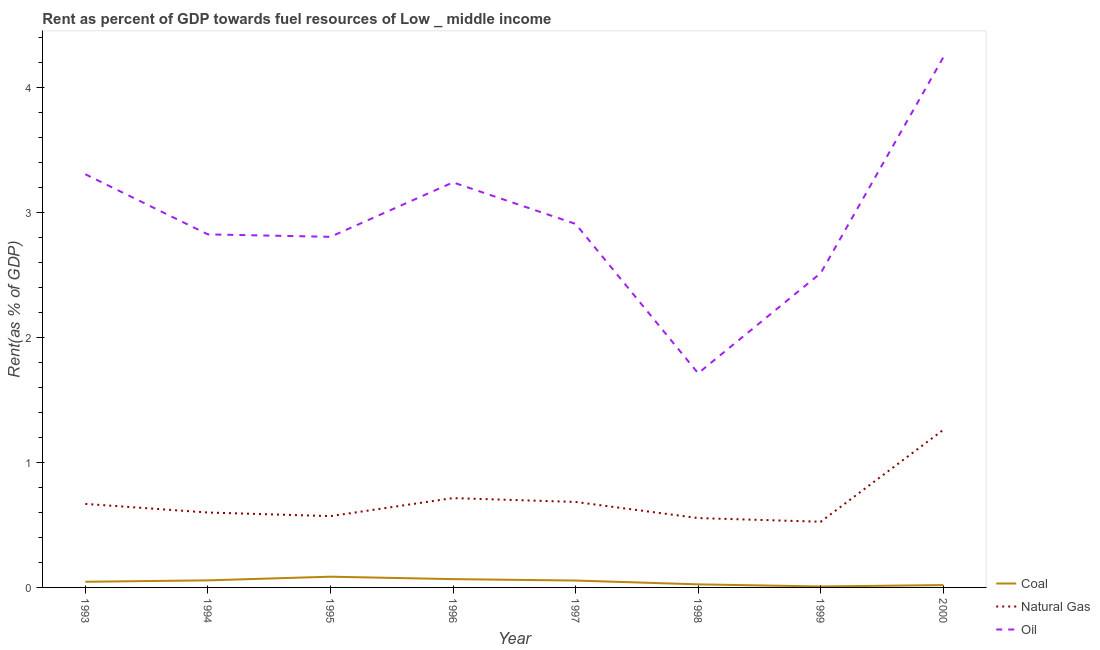Does the line corresponding to rent towards oil intersect with the line corresponding to rent towards natural gas?
Make the answer very short. No. Is the number of lines equal to the number of legend labels?
Your answer should be very brief. Yes. What is the rent towards coal in 1996?
Your answer should be very brief. 0.07. Across all years, what is the maximum rent towards natural gas?
Offer a very short reply. 1.26. Across all years, what is the minimum rent towards natural gas?
Keep it short and to the point. 0.53. In which year was the rent towards coal minimum?
Your response must be concise. 1999. What is the total rent towards coal in the graph?
Make the answer very short. 0.36. What is the difference between the rent towards coal in 1994 and that in 1996?
Your answer should be very brief. -0.01. What is the difference between the rent towards natural gas in 1997 and the rent towards coal in 1996?
Provide a short and direct response. 0.62. What is the average rent towards natural gas per year?
Make the answer very short. 0.7. In the year 1995, what is the difference between the rent towards coal and rent towards oil?
Ensure brevity in your answer.  -2.72. In how many years, is the rent towards coal greater than 3.2 %?
Keep it short and to the point. 0. What is the ratio of the rent towards coal in 1995 to that in 1996?
Your response must be concise. 1.29. Is the rent towards coal in 1994 less than that in 1998?
Provide a succinct answer. No. Is the difference between the rent towards natural gas in 1993 and 1998 greater than the difference between the rent towards coal in 1993 and 1998?
Keep it short and to the point. Yes. What is the difference between the highest and the second highest rent towards coal?
Make the answer very short. 0.02. What is the difference between the highest and the lowest rent towards oil?
Give a very brief answer. 2.53. In how many years, is the rent towards coal greater than the average rent towards coal taken over all years?
Your response must be concise. 5. Is the sum of the rent towards oil in 1994 and 1996 greater than the maximum rent towards natural gas across all years?
Offer a very short reply. Yes. Is it the case that in every year, the sum of the rent towards coal and rent towards natural gas is greater than the rent towards oil?
Ensure brevity in your answer.  No. Does the rent towards natural gas monotonically increase over the years?
Ensure brevity in your answer.  No. Is the rent towards oil strictly less than the rent towards coal over the years?
Give a very brief answer. No. How many years are there in the graph?
Provide a short and direct response. 8. Are the values on the major ticks of Y-axis written in scientific E-notation?
Your response must be concise. No. Where does the legend appear in the graph?
Offer a terse response. Bottom right. How many legend labels are there?
Ensure brevity in your answer.  3. What is the title of the graph?
Give a very brief answer. Rent as percent of GDP towards fuel resources of Low _ middle income. What is the label or title of the Y-axis?
Provide a succinct answer. Rent(as % of GDP). What is the Rent(as % of GDP) of Coal in 1993?
Provide a succinct answer. 0.05. What is the Rent(as % of GDP) in Natural Gas in 1993?
Make the answer very short. 0.67. What is the Rent(as % of GDP) in Oil in 1993?
Your answer should be compact. 3.3. What is the Rent(as % of GDP) of Coal in 1994?
Offer a very short reply. 0.06. What is the Rent(as % of GDP) of Natural Gas in 1994?
Your response must be concise. 0.6. What is the Rent(as % of GDP) in Oil in 1994?
Give a very brief answer. 2.82. What is the Rent(as % of GDP) of Coal in 1995?
Keep it short and to the point. 0.09. What is the Rent(as % of GDP) in Natural Gas in 1995?
Provide a succinct answer. 0.57. What is the Rent(as % of GDP) of Oil in 1995?
Provide a succinct answer. 2.8. What is the Rent(as % of GDP) in Coal in 1996?
Offer a terse response. 0.07. What is the Rent(as % of GDP) in Natural Gas in 1996?
Make the answer very short. 0.71. What is the Rent(as % of GDP) of Oil in 1996?
Make the answer very short. 3.24. What is the Rent(as % of GDP) of Coal in 1997?
Give a very brief answer. 0.06. What is the Rent(as % of GDP) of Natural Gas in 1997?
Your response must be concise. 0.68. What is the Rent(as % of GDP) in Oil in 1997?
Your response must be concise. 2.91. What is the Rent(as % of GDP) of Coal in 1998?
Keep it short and to the point. 0.02. What is the Rent(as % of GDP) of Natural Gas in 1998?
Provide a short and direct response. 0.55. What is the Rent(as % of GDP) of Oil in 1998?
Offer a very short reply. 1.71. What is the Rent(as % of GDP) of Coal in 1999?
Ensure brevity in your answer.  0.01. What is the Rent(as % of GDP) of Natural Gas in 1999?
Keep it short and to the point. 0.53. What is the Rent(as % of GDP) in Oil in 1999?
Keep it short and to the point. 2.51. What is the Rent(as % of GDP) of Coal in 2000?
Make the answer very short. 0.02. What is the Rent(as % of GDP) of Natural Gas in 2000?
Your answer should be compact. 1.26. What is the Rent(as % of GDP) in Oil in 2000?
Your response must be concise. 4.24. Across all years, what is the maximum Rent(as % of GDP) in Coal?
Your answer should be very brief. 0.09. Across all years, what is the maximum Rent(as % of GDP) of Natural Gas?
Give a very brief answer. 1.26. Across all years, what is the maximum Rent(as % of GDP) in Oil?
Offer a very short reply. 4.24. Across all years, what is the minimum Rent(as % of GDP) in Coal?
Provide a succinct answer. 0.01. Across all years, what is the minimum Rent(as % of GDP) in Natural Gas?
Give a very brief answer. 0.53. Across all years, what is the minimum Rent(as % of GDP) of Oil?
Keep it short and to the point. 1.71. What is the total Rent(as % of GDP) of Coal in the graph?
Your answer should be compact. 0.36. What is the total Rent(as % of GDP) in Natural Gas in the graph?
Keep it short and to the point. 5.57. What is the total Rent(as % of GDP) in Oil in the graph?
Ensure brevity in your answer.  23.54. What is the difference between the Rent(as % of GDP) in Coal in 1993 and that in 1994?
Offer a terse response. -0.01. What is the difference between the Rent(as % of GDP) of Natural Gas in 1993 and that in 1994?
Your response must be concise. 0.07. What is the difference between the Rent(as % of GDP) of Oil in 1993 and that in 1994?
Offer a very short reply. 0.48. What is the difference between the Rent(as % of GDP) in Coal in 1993 and that in 1995?
Your answer should be very brief. -0.04. What is the difference between the Rent(as % of GDP) in Natural Gas in 1993 and that in 1995?
Offer a terse response. 0.1. What is the difference between the Rent(as % of GDP) of Oil in 1993 and that in 1995?
Your answer should be compact. 0.5. What is the difference between the Rent(as % of GDP) of Coal in 1993 and that in 1996?
Your response must be concise. -0.02. What is the difference between the Rent(as % of GDP) of Natural Gas in 1993 and that in 1996?
Keep it short and to the point. -0.05. What is the difference between the Rent(as % of GDP) of Oil in 1993 and that in 1996?
Your response must be concise. 0.07. What is the difference between the Rent(as % of GDP) in Coal in 1993 and that in 1997?
Make the answer very short. -0.01. What is the difference between the Rent(as % of GDP) of Natural Gas in 1993 and that in 1997?
Give a very brief answer. -0.02. What is the difference between the Rent(as % of GDP) of Oil in 1993 and that in 1997?
Provide a short and direct response. 0.4. What is the difference between the Rent(as % of GDP) in Coal in 1993 and that in 1998?
Offer a very short reply. 0.02. What is the difference between the Rent(as % of GDP) of Natural Gas in 1993 and that in 1998?
Provide a short and direct response. 0.11. What is the difference between the Rent(as % of GDP) in Oil in 1993 and that in 1998?
Your answer should be very brief. 1.59. What is the difference between the Rent(as % of GDP) in Coal in 1993 and that in 1999?
Your response must be concise. 0.04. What is the difference between the Rent(as % of GDP) of Natural Gas in 1993 and that in 1999?
Offer a very short reply. 0.14. What is the difference between the Rent(as % of GDP) of Oil in 1993 and that in 1999?
Offer a very short reply. 0.79. What is the difference between the Rent(as % of GDP) of Coal in 1993 and that in 2000?
Provide a short and direct response. 0.03. What is the difference between the Rent(as % of GDP) in Natural Gas in 1993 and that in 2000?
Provide a succinct answer. -0.59. What is the difference between the Rent(as % of GDP) of Oil in 1993 and that in 2000?
Your response must be concise. -0.93. What is the difference between the Rent(as % of GDP) of Coal in 1994 and that in 1995?
Offer a terse response. -0.03. What is the difference between the Rent(as % of GDP) of Natural Gas in 1994 and that in 1995?
Give a very brief answer. 0.03. What is the difference between the Rent(as % of GDP) of Oil in 1994 and that in 1995?
Your response must be concise. 0.02. What is the difference between the Rent(as % of GDP) in Coal in 1994 and that in 1996?
Give a very brief answer. -0.01. What is the difference between the Rent(as % of GDP) of Natural Gas in 1994 and that in 1996?
Provide a succinct answer. -0.12. What is the difference between the Rent(as % of GDP) in Oil in 1994 and that in 1996?
Provide a succinct answer. -0.42. What is the difference between the Rent(as % of GDP) of Coal in 1994 and that in 1997?
Your answer should be very brief. 0. What is the difference between the Rent(as % of GDP) of Natural Gas in 1994 and that in 1997?
Your answer should be compact. -0.08. What is the difference between the Rent(as % of GDP) of Oil in 1994 and that in 1997?
Your answer should be compact. -0.08. What is the difference between the Rent(as % of GDP) of Coal in 1994 and that in 1998?
Provide a succinct answer. 0.03. What is the difference between the Rent(as % of GDP) in Natural Gas in 1994 and that in 1998?
Give a very brief answer. 0.04. What is the difference between the Rent(as % of GDP) in Oil in 1994 and that in 1998?
Give a very brief answer. 1.11. What is the difference between the Rent(as % of GDP) of Coal in 1994 and that in 1999?
Keep it short and to the point. 0.05. What is the difference between the Rent(as % of GDP) in Natural Gas in 1994 and that in 1999?
Give a very brief answer. 0.07. What is the difference between the Rent(as % of GDP) in Oil in 1994 and that in 1999?
Provide a succinct answer. 0.31. What is the difference between the Rent(as % of GDP) in Coal in 1994 and that in 2000?
Your answer should be compact. 0.04. What is the difference between the Rent(as % of GDP) in Natural Gas in 1994 and that in 2000?
Your answer should be very brief. -0.66. What is the difference between the Rent(as % of GDP) of Oil in 1994 and that in 2000?
Offer a terse response. -1.42. What is the difference between the Rent(as % of GDP) of Coal in 1995 and that in 1996?
Make the answer very short. 0.02. What is the difference between the Rent(as % of GDP) of Natural Gas in 1995 and that in 1996?
Keep it short and to the point. -0.14. What is the difference between the Rent(as % of GDP) in Oil in 1995 and that in 1996?
Your response must be concise. -0.44. What is the difference between the Rent(as % of GDP) in Coal in 1995 and that in 1997?
Give a very brief answer. 0.03. What is the difference between the Rent(as % of GDP) in Natural Gas in 1995 and that in 1997?
Provide a succinct answer. -0.11. What is the difference between the Rent(as % of GDP) of Oil in 1995 and that in 1997?
Keep it short and to the point. -0.1. What is the difference between the Rent(as % of GDP) of Coal in 1995 and that in 1998?
Your response must be concise. 0.06. What is the difference between the Rent(as % of GDP) in Natural Gas in 1995 and that in 1998?
Offer a terse response. 0.02. What is the difference between the Rent(as % of GDP) of Oil in 1995 and that in 1998?
Give a very brief answer. 1.09. What is the difference between the Rent(as % of GDP) in Coal in 1995 and that in 1999?
Your response must be concise. 0.08. What is the difference between the Rent(as % of GDP) of Natural Gas in 1995 and that in 1999?
Make the answer very short. 0.04. What is the difference between the Rent(as % of GDP) of Oil in 1995 and that in 1999?
Your response must be concise. 0.29. What is the difference between the Rent(as % of GDP) of Coal in 1995 and that in 2000?
Provide a short and direct response. 0.07. What is the difference between the Rent(as % of GDP) of Natural Gas in 1995 and that in 2000?
Offer a very short reply. -0.69. What is the difference between the Rent(as % of GDP) in Oil in 1995 and that in 2000?
Provide a short and direct response. -1.44. What is the difference between the Rent(as % of GDP) in Coal in 1996 and that in 1997?
Offer a very short reply. 0.01. What is the difference between the Rent(as % of GDP) of Natural Gas in 1996 and that in 1997?
Your response must be concise. 0.03. What is the difference between the Rent(as % of GDP) in Oil in 1996 and that in 1997?
Offer a terse response. 0.33. What is the difference between the Rent(as % of GDP) of Coal in 1996 and that in 1998?
Your answer should be compact. 0.04. What is the difference between the Rent(as % of GDP) in Natural Gas in 1996 and that in 1998?
Ensure brevity in your answer.  0.16. What is the difference between the Rent(as % of GDP) in Oil in 1996 and that in 1998?
Offer a terse response. 1.53. What is the difference between the Rent(as % of GDP) in Coal in 1996 and that in 1999?
Ensure brevity in your answer.  0.06. What is the difference between the Rent(as % of GDP) of Natural Gas in 1996 and that in 1999?
Provide a succinct answer. 0.19. What is the difference between the Rent(as % of GDP) in Oil in 1996 and that in 1999?
Your answer should be very brief. 0.72. What is the difference between the Rent(as % of GDP) of Coal in 1996 and that in 2000?
Provide a succinct answer. 0.05. What is the difference between the Rent(as % of GDP) in Natural Gas in 1996 and that in 2000?
Keep it short and to the point. -0.55. What is the difference between the Rent(as % of GDP) of Coal in 1997 and that in 1998?
Your answer should be very brief. 0.03. What is the difference between the Rent(as % of GDP) of Natural Gas in 1997 and that in 1998?
Keep it short and to the point. 0.13. What is the difference between the Rent(as % of GDP) of Oil in 1997 and that in 1998?
Offer a very short reply. 1.19. What is the difference between the Rent(as % of GDP) of Coal in 1997 and that in 1999?
Offer a very short reply. 0.05. What is the difference between the Rent(as % of GDP) of Natural Gas in 1997 and that in 1999?
Give a very brief answer. 0.16. What is the difference between the Rent(as % of GDP) of Oil in 1997 and that in 1999?
Provide a short and direct response. 0.39. What is the difference between the Rent(as % of GDP) of Coal in 1997 and that in 2000?
Keep it short and to the point. 0.04. What is the difference between the Rent(as % of GDP) in Natural Gas in 1997 and that in 2000?
Offer a terse response. -0.58. What is the difference between the Rent(as % of GDP) in Oil in 1997 and that in 2000?
Your answer should be very brief. -1.33. What is the difference between the Rent(as % of GDP) in Coal in 1998 and that in 1999?
Your answer should be very brief. 0.02. What is the difference between the Rent(as % of GDP) in Natural Gas in 1998 and that in 1999?
Your response must be concise. 0.03. What is the difference between the Rent(as % of GDP) in Oil in 1998 and that in 1999?
Ensure brevity in your answer.  -0.8. What is the difference between the Rent(as % of GDP) in Coal in 1998 and that in 2000?
Offer a very short reply. 0.01. What is the difference between the Rent(as % of GDP) of Natural Gas in 1998 and that in 2000?
Offer a terse response. -0.71. What is the difference between the Rent(as % of GDP) of Oil in 1998 and that in 2000?
Provide a succinct answer. -2.53. What is the difference between the Rent(as % of GDP) of Coal in 1999 and that in 2000?
Your response must be concise. -0.01. What is the difference between the Rent(as % of GDP) in Natural Gas in 1999 and that in 2000?
Provide a succinct answer. -0.73. What is the difference between the Rent(as % of GDP) in Oil in 1999 and that in 2000?
Make the answer very short. -1.73. What is the difference between the Rent(as % of GDP) of Coal in 1993 and the Rent(as % of GDP) of Natural Gas in 1994?
Offer a terse response. -0.55. What is the difference between the Rent(as % of GDP) of Coal in 1993 and the Rent(as % of GDP) of Oil in 1994?
Your answer should be compact. -2.78. What is the difference between the Rent(as % of GDP) in Natural Gas in 1993 and the Rent(as % of GDP) in Oil in 1994?
Your answer should be very brief. -2.15. What is the difference between the Rent(as % of GDP) of Coal in 1993 and the Rent(as % of GDP) of Natural Gas in 1995?
Keep it short and to the point. -0.52. What is the difference between the Rent(as % of GDP) of Coal in 1993 and the Rent(as % of GDP) of Oil in 1995?
Provide a succinct answer. -2.76. What is the difference between the Rent(as % of GDP) in Natural Gas in 1993 and the Rent(as % of GDP) in Oil in 1995?
Your answer should be very brief. -2.14. What is the difference between the Rent(as % of GDP) in Coal in 1993 and the Rent(as % of GDP) in Natural Gas in 1996?
Your answer should be compact. -0.67. What is the difference between the Rent(as % of GDP) in Coal in 1993 and the Rent(as % of GDP) in Oil in 1996?
Your response must be concise. -3.19. What is the difference between the Rent(as % of GDP) in Natural Gas in 1993 and the Rent(as % of GDP) in Oil in 1996?
Ensure brevity in your answer.  -2.57. What is the difference between the Rent(as % of GDP) in Coal in 1993 and the Rent(as % of GDP) in Natural Gas in 1997?
Ensure brevity in your answer.  -0.64. What is the difference between the Rent(as % of GDP) of Coal in 1993 and the Rent(as % of GDP) of Oil in 1997?
Your answer should be very brief. -2.86. What is the difference between the Rent(as % of GDP) of Natural Gas in 1993 and the Rent(as % of GDP) of Oil in 1997?
Offer a very short reply. -2.24. What is the difference between the Rent(as % of GDP) in Coal in 1993 and the Rent(as % of GDP) in Natural Gas in 1998?
Your answer should be compact. -0.51. What is the difference between the Rent(as % of GDP) in Coal in 1993 and the Rent(as % of GDP) in Oil in 1998?
Offer a very short reply. -1.67. What is the difference between the Rent(as % of GDP) of Natural Gas in 1993 and the Rent(as % of GDP) of Oil in 1998?
Your answer should be compact. -1.04. What is the difference between the Rent(as % of GDP) in Coal in 1993 and the Rent(as % of GDP) in Natural Gas in 1999?
Keep it short and to the point. -0.48. What is the difference between the Rent(as % of GDP) of Coal in 1993 and the Rent(as % of GDP) of Oil in 1999?
Offer a terse response. -2.47. What is the difference between the Rent(as % of GDP) in Natural Gas in 1993 and the Rent(as % of GDP) in Oil in 1999?
Offer a terse response. -1.85. What is the difference between the Rent(as % of GDP) of Coal in 1993 and the Rent(as % of GDP) of Natural Gas in 2000?
Provide a short and direct response. -1.21. What is the difference between the Rent(as % of GDP) in Coal in 1993 and the Rent(as % of GDP) in Oil in 2000?
Offer a very short reply. -4.19. What is the difference between the Rent(as % of GDP) of Natural Gas in 1993 and the Rent(as % of GDP) of Oil in 2000?
Your response must be concise. -3.57. What is the difference between the Rent(as % of GDP) of Coal in 1994 and the Rent(as % of GDP) of Natural Gas in 1995?
Make the answer very short. -0.51. What is the difference between the Rent(as % of GDP) of Coal in 1994 and the Rent(as % of GDP) of Oil in 1995?
Ensure brevity in your answer.  -2.75. What is the difference between the Rent(as % of GDP) in Natural Gas in 1994 and the Rent(as % of GDP) in Oil in 1995?
Your response must be concise. -2.2. What is the difference between the Rent(as % of GDP) in Coal in 1994 and the Rent(as % of GDP) in Natural Gas in 1996?
Offer a terse response. -0.66. What is the difference between the Rent(as % of GDP) of Coal in 1994 and the Rent(as % of GDP) of Oil in 1996?
Your response must be concise. -3.18. What is the difference between the Rent(as % of GDP) of Natural Gas in 1994 and the Rent(as % of GDP) of Oil in 1996?
Keep it short and to the point. -2.64. What is the difference between the Rent(as % of GDP) in Coal in 1994 and the Rent(as % of GDP) in Natural Gas in 1997?
Ensure brevity in your answer.  -0.63. What is the difference between the Rent(as % of GDP) of Coal in 1994 and the Rent(as % of GDP) of Oil in 1997?
Offer a terse response. -2.85. What is the difference between the Rent(as % of GDP) of Natural Gas in 1994 and the Rent(as % of GDP) of Oil in 1997?
Give a very brief answer. -2.31. What is the difference between the Rent(as % of GDP) of Coal in 1994 and the Rent(as % of GDP) of Natural Gas in 1998?
Your answer should be very brief. -0.5. What is the difference between the Rent(as % of GDP) in Coal in 1994 and the Rent(as % of GDP) in Oil in 1998?
Your answer should be very brief. -1.66. What is the difference between the Rent(as % of GDP) of Natural Gas in 1994 and the Rent(as % of GDP) of Oil in 1998?
Make the answer very short. -1.11. What is the difference between the Rent(as % of GDP) in Coal in 1994 and the Rent(as % of GDP) in Natural Gas in 1999?
Your response must be concise. -0.47. What is the difference between the Rent(as % of GDP) in Coal in 1994 and the Rent(as % of GDP) in Oil in 1999?
Offer a very short reply. -2.46. What is the difference between the Rent(as % of GDP) in Natural Gas in 1994 and the Rent(as % of GDP) in Oil in 1999?
Your answer should be compact. -1.91. What is the difference between the Rent(as % of GDP) in Coal in 1994 and the Rent(as % of GDP) in Natural Gas in 2000?
Offer a very short reply. -1.2. What is the difference between the Rent(as % of GDP) of Coal in 1994 and the Rent(as % of GDP) of Oil in 2000?
Make the answer very short. -4.18. What is the difference between the Rent(as % of GDP) of Natural Gas in 1994 and the Rent(as % of GDP) of Oil in 2000?
Your answer should be compact. -3.64. What is the difference between the Rent(as % of GDP) in Coal in 1995 and the Rent(as % of GDP) in Natural Gas in 1996?
Your response must be concise. -0.63. What is the difference between the Rent(as % of GDP) of Coal in 1995 and the Rent(as % of GDP) of Oil in 1996?
Ensure brevity in your answer.  -3.15. What is the difference between the Rent(as % of GDP) in Natural Gas in 1995 and the Rent(as % of GDP) in Oil in 1996?
Give a very brief answer. -2.67. What is the difference between the Rent(as % of GDP) in Coal in 1995 and the Rent(as % of GDP) in Natural Gas in 1997?
Provide a succinct answer. -0.6. What is the difference between the Rent(as % of GDP) in Coal in 1995 and the Rent(as % of GDP) in Oil in 1997?
Offer a terse response. -2.82. What is the difference between the Rent(as % of GDP) in Natural Gas in 1995 and the Rent(as % of GDP) in Oil in 1997?
Your response must be concise. -2.34. What is the difference between the Rent(as % of GDP) in Coal in 1995 and the Rent(as % of GDP) in Natural Gas in 1998?
Provide a succinct answer. -0.47. What is the difference between the Rent(as % of GDP) in Coal in 1995 and the Rent(as % of GDP) in Oil in 1998?
Your answer should be very brief. -1.63. What is the difference between the Rent(as % of GDP) in Natural Gas in 1995 and the Rent(as % of GDP) in Oil in 1998?
Ensure brevity in your answer.  -1.14. What is the difference between the Rent(as % of GDP) of Coal in 1995 and the Rent(as % of GDP) of Natural Gas in 1999?
Keep it short and to the point. -0.44. What is the difference between the Rent(as % of GDP) in Coal in 1995 and the Rent(as % of GDP) in Oil in 1999?
Your answer should be very brief. -2.43. What is the difference between the Rent(as % of GDP) in Natural Gas in 1995 and the Rent(as % of GDP) in Oil in 1999?
Provide a succinct answer. -1.94. What is the difference between the Rent(as % of GDP) of Coal in 1995 and the Rent(as % of GDP) of Natural Gas in 2000?
Provide a succinct answer. -1.17. What is the difference between the Rent(as % of GDP) in Coal in 1995 and the Rent(as % of GDP) in Oil in 2000?
Keep it short and to the point. -4.15. What is the difference between the Rent(as % of GDP) of Natural Gas in 1995 and the Rent(as % of GDP) of Oil in 2000?
Ensure brevity in your answer.  -3.67. What is the difference between the Rent(as % of GDP) of Coal in 1996 and the Rent(as % of GDP) of Natural Gas in 1997?
Your answer should be compact. -0.62. What is the difference between the Rent(as % of GDP) in Coal in 1996 and the Rent(as % of GDP) in Oil in 1997?
Keep it short and to the point. -2.84. What is the difference between the Rent(as % of GDP) in Natural Gas in 1996 and the Rent(as % of GDP) in Oil in 1997?
Provide a short and direct response. -2.19. What is the difference between the Rent(as % of GDP) of Coal in 1996 and the Rent(as % of GDP) of Natural Gas in 1998?
Give a very brief answer. -0.49. What is the difference between the Rent(as % of GDP) of Coal in 1996 and the Rent(as % of GDP) of Oil in 1998?
Provide a short and direct response. -1.65. What is the difference between the Rent(as % of GDP) in Natural Gas in 1996 and the Rent(as % of GDP) in Oil in 1998?
Your answer should be very brief. -1. What is the difference between the Rent(as % of GDP) of Coal in 1996 and the Rent(as % of GDP) of Natural Gas in 1999?
Give a very brief answer. -0.46. What is the difference between the Rent(as % of GDP) of Coal in 1996 and the Rent(as % of GDP) of Oil in 1999?
Provide a short and direct response. -2.45. What is the difference between the Rent(as % of GDP) of Natural Gas in 1996 and the Rent(as % of GDP) of Oil in 1999?
Ensure brevity in your answer.  -1.8. What is the difference between the Rent(as % of GDP) of Coal in 1996 and the Rent(as % of GDP) of Natural Gas in 2000?
Your answer should be very brief. -1.19. What is the difference between the Rent(as % of GDP) in Coal in 1996 and the Rent(as % of GDP) in Oil in 2000?
Your answer should be very brief. -4.17. What is the difference between the Rent(as % of GDP) in Natural Gas in 1996 and the Rent(as % of GDP) in Oil in 2000?
Offer a terse response. -3.52. What is the difference between the Rent(as % of GDP) of Coal in 1997 and the Rent(as % of GDP) of Natural Gas in 1998?
Keep it short and to the point. -0.5. What is the difference between the Rent(as % of GDP) in Coal in 1997 and the Rent(as % of GDP) in Oil in 1998?
Provide a succinct answer. -1.66. What is the difference between the Rent(as % of GDP) of Natural Gas in 1997 and the Rent(as % of GDP) of Oil in 1998?
Provide a short and direct response. -1.03. What is the difference between the Rent(as % of GDP) of Coal in 1997 and the Rent(as % of GDP) of Natural Gas in 1999?
Provide a succinct answer. -0.47. What is the difference between the Rent(as % of GDP) in Coal in 1997 and the Rent(as % of GDP) in Oil in 1999?
Your answer should be very brief. -2.46. What is the difference between the Rent(as % of GDP) in Natural Gas in 1997 and the Rent(as % of GDP) in Oil in 1999?
Your answer should be very brief. -1.83. What is the difference between the Rent(as % of GDP) of Coal in 1997 and the Rent(as % of GDP) of Natural Gas in 2000?
Your response must be concise. -1.2. What is the difference between the Rent(as % of GDP) in Coal in 1997 and the Rent(as % of GDP) in Oil in 2000?
Provide a succinct answer. -4.18. What is the difference between the Rent(as % of GDP) of Natural Gas in 1997 and the Rent(as % of GDP) of Oil in 2000?
Keep it short and to the point. -3.55. What is the difference between the Rent(as % of GDP) in Coal in 1998 and the Rent(as % of GDP) in Natural Gas in 1999?
Make the answer very short. -0.5. What is the difference between the Rent(as % of GDP) of Coal in 1998 and the Rent(as % of GDP) of Oil in 1999?
Provide a short and direct response. -2.49. What is the difference between the Rent(as % of GDP) of Natural Gas in 1998 and the Rent(as % of GDP) of Oil in 1999?
Offer a terse response. -1.96. What is the difference between the Rent(as % of GDP) in Coal in 1998 and the Rent(as % of GDP) in Natural Gas in 2000?
Ensure brevity in your answer.  -1.24. What is the difference between the Rent(as % of GDP) of Coal in 1998 and the Rent(as % of GDP) of Oil in 2000?
Provide a short and direct response. -4.21. What is the difference between the Rent(as % of GDP) in Natural Gas in 1998 and the Rent(as % of GDP) in Oil in 2000?
Your answer should be compact. -3.68. What is the difference between the Rent(as % of GDP) of Coal in 1999 and the Rent(as % of GDP) of Natural Gas in 2000?
Keep it short and to the point. -1.25. What is the difference between the Rent(as % of GDP) of Coal in 1999 and the Rent(as % of GDP) of Oil in 2000?
Make the answer very short. -4.23. What is the difference between the Rent(as % of GDP) of Natural Gas in 1999 and the Rent(as % of GDP) of Oil in 2000?
Give a very brief answer. -3.71. What is the average Rent(as % of GDP) of Coal per year?
Give a very brief answer. 0.04. What is the average Rent(as % of GDP) in Natural Gas per year?
Offer a very short reply. 0.7. What is the average Rent(as % of GDP) of Oil per year?
Your answer should be compact. 2.94. In the year 1993, what is the difference between the Rent(as % of GDP) in Coal and Rent(as % of GDP) in Natural Gas?
Give a very brief answer. -0.62. In the year 1993, what is the difference between the Rent(as % of GDP) in Coal and Rent(as % of GDP) in Oil?
Keep it short and to the point. -3.26. In the year 1993, what is the difference between the Rent(as % of GDP) in Natural Gas and Rent(as % of GDP) in Oil?
Offer a terse response. -2.64. In the year 1994, what is the difference between the Rent(as % of GDP) in Coal and Rent(as % of GDP) in Natural Gas?
Offer a very short reply. -0.54. In the year 1994, what is the difference between the Rent(as % of GDP) in Coal and Rent(as % of GDP) in Oil?
Keep it short and to the point. -2.77. In the year 1994, what is the difference between the Rent(as % of GDP) of Natural Gas and Rent(as % of GDP) of Oil?
Your answer should be very brief. -2.22. In the year 1995, what is the difference between the Rent(as % of GDP) of Coal and Rent(as % of GDP) of Natural Gas?
Offer a very short reply. -0.48. In the year 1995, what is the difference between the Rent(as % of GDP) of Coal and Rent(as % of GDP) of Oil?
Provide a short and direct response. -2.72. In the year 1995, what is the difference between the Rent(as % of GDP) of Natural Gas and Rent(as % of GDP) of Oil?
Keep it short and to the point. -2.23. In the year 1996, what is the difference between the Rent(as % of GDP) in Coal and Rent(as % of GDP) in Natural Gas?
Your response must be concise. -0.65. In the year 1996, what is the difference between the Rent(as % of GDP) of Coal and Rent(as % of GDP) of Oil?
Keep it short and to the point. -3.17. In the year 1996, what is the difference between the Rent(as % of GDP) in Natural Gas and Rent(as % of GDP) in Oil?
Your answer should be very brief. -2.52. In the year 1997, what is the difference between the Rent(as % of GDP) in Coal and Rent(as % of GDP) in Natural Gas?
Make the answer very short. -0.63. In the year 1997, what is the difference between the Rent(as % of GDP) in Coal and Rent(as % of GDP) in Oil?
Provide a short and direct response. -2.85. In the year 1997, what is the difference between the Rent(as % of GDP) of Natural Gas and Rent(as % of GDP) of Oil?
Your response must be concise. -2.22. In the year 1998, what is the difference between the Rent(as % of GDP) in Coal and Rent(as % of GDP) in Natural Gas?
Give a very brief answer. -0.53. In the year 1998, what is the difference between the Rent(as % of GDP) in Coal and Rent(as % of GDP) in Oil?
Provide a short and direct response. -1.69. In the year 1998, what is the difference between the Rent(as % of GDP) in Natural Gas and Rent(as % of GDP) in Oil?
Offer a terse response. -1.16. In the year 1999, what is the difference between the Rent(as % of GDP) in Coal and Rent(as % of GDP) in Natural Gas?
Your answer should be compact. -0.52. In the year 1999, what is the difference between the Rent(as % of GDP) in Coal and Rent(as % of GDP) in Oil?
Offer a terse response. -2.51. In the year 1999, what is the difference between the Rent(as % of GDP) in Natural Gas and Rent(as % of GDP) in Oil?
Provide a short and direct response. -1.99. In the year 2000, what is the difference between the Rent(as % of GDP) in Coal and Rent(as % of GDP) in Natural Gas?
Your answer should be compact. -1.24. In the year 2000, what is the difference between the Rent(as % of GDP) in Coal and Rent(as % of GDP) in Oil?
Offer a very short reply. -4.22. In the year 2000, what is the difference between the Rent(as % of GDP) of Natural Gas and Rent(as % of GDP) of Oil?
Provide a succinct answer. -2.98. What is the ratio of the Rent(as % of GDP) in Coal in 1993 to that in 1994?
Offer a very short reply. 0.8. What is the ratio of the Rent(as % of GDP) of Natural Gas in 1993 to that in 1994?
Provide a short and direct response. 1.11. What is the ratio of the Rent(as % of GDP) in Oil in 1993 to that in 1994?
Make the answer very short. 1.17. What is the ratio of the Rent(as % of GDP) of Coal in 1993 to that in 1995?
Offer a terse response. 0.53. What is the ratio of the Rent(as % of GDP) of Natural Gas in 1993 to that in 1995?
Offer a very short reply. 1.17. What is the ratio of the Rent(as % of GDP) of Oil in 1993 to that in 1995?
Provide a short and direct response. 1.18. What is the ratio of the Rent(as % of GDP) in Coal in 1993 to that in 1996?
Ensure brevity in your answer.  0.68. What is the ratio of the Rent(as % of GDP) in Natural Gas in 1993 to that in 1996?
Make the answer very short. 0.93. What is the ratio of the Rent(as % of GDP) of Oil in 1993 to that in 1996?
Keep it short and to the point. 1.02. What is the ratio of the Rent(as % of GDP) of Coal in 1993 to that in 1997?
Ensure brevity in your answer.  0.82. What is the ratio of the Rent(as % of GDP) in Natural Gas in 1993 to that in 1997?
Provide a succinct answer. 0.98. What is the ratio of the Rent(as % of GDP) of Oil in 1993 to that in 1997?
Give a very brief answer. 1.14. What is the ratio of the Rent(as % of GDP) of Coal in 1993 to that in 1998?
Offer a very short reply. 1.85. What is the ratio of the Rent(as % of GDP) of Natural Gas in 1993 to that in 1998?
Give a very brief answer. 1.2. What is the ratio of the Rent(as % of GDP) of Oil in 1993 to that in 1998?
Your answer should be compact. 1.93. What is the ratio of the Rent(as % of GDP) in Coal in 1993 to that in 1999?
Provide a short and direct response. 5.94. What is the ratio of the Rent(as % of GDP) of Natural Gas in 1993 to that in 1999?
Provide a short and direct response. 1.27. What is the ratio of the Rent(as % of GDP) of Oil in 1993 to that in 1999?
Your answer should be compact. 1.31. What is the ratio of the Rent(as % of GDP) in Coal in 1993 to that in 2000?
Provide a succinct answer. 2.41. What is the ratio of the Rent(as % of GDP) of Natural Gas in 1993 to that in 2000?
Offer a terse response. 0.53. What is the ratio of the Rent(as % of GDP) in Oil in 1993 to that in 2000?
Ensure brevity in your answer.  0.78. What is the ratio of the Rent(as % of GDP) of Coal in 1994 to that in 1995?
Offer a very short reply. 0.66. What is the ratio of the Rent(as % of GDP) of Natural Gas in 1994 to that in 1995?
Offer a terse response. 1.05. What is the ratio of the Rent(as % of GDP) in Oil in 1994 to that in 1995?
Offer a terse response. 1.01. What is the ratio of the Rent(as % of GDP) in Coal in 1994 to that in 1996?
Your response must be concise. 0.85. What is the ratio of the Rent(as % of GDP) in Natural Gas in 1994 to that in 1996?
Ensure brevity in your answer.  0.84. What is the ratio of the Rent(as % of GDP) of Oil in 1994 to that in 1996?
Your answer should be very brief. 0.87. What is the ratio of the Rent(as % of GDP) of Coal in 1994 to that in 1997?
Your answer should be very brief. 1.03. What is the ratio of the Rent(as % of GDP) in Natural Gas in 1994 to that in 1997?
Keep it short and to the point. 0.88. What is the ratio of the Rent(as % of GDP) of Oil in 1994 to that in 1997?
Provide a short and direct response. 0.97. What is the ratio of the Rent(as % of GDP) in Coal in 1994 to that in 1998?
Your answer should be very brief. 2.31. What is the ratio of the Rent(as % of GDP) in Natural Gas in 1994 to that in 1998?
Make the answer very short. 1.08. What is the ratio of the Rent(as % of GDP) in Oil in 1994 to that in 1998?
Your answer should be compact. 1.65. What is the ratio of the Rent(as % of GDP) in Coal in 1994 to that in 1999?
Provide a short and direct response. 7.41. What is the ratio of the Rent(as % of GDP) of Natural Gas in 1994 to that in 1999?
Offer a terse response. 1.14. What is the ratio of the Rent(as % of GDP) in Oil in 1994 to that in 1999?
Offer a very short reply. 1.12. What is the ratio of the Rent(as % of GDP) in Coal in 1994 to that in 2000?
Offer a very short reply. 3.01. What is the ratio of the Rent(as % of GDP) of Natural Gas in 1994 to that in 2000?
Offer a very short reply. 0.48. What is the ratio of the Rent(as % of GDP) in Oil in 1994 to that in 2000?
Provide a succinct answer. 0.67. What is the ratio of the Rent(as % of GDP) of Coal in 1995 to that in 1996?
Make the answer very short. 1.29. What is the ratio of the Rent(as % of GDP) in Natural Gas in 1995 to that in 1996?
Provide a succinct answer. 0.8. What is the ratio of the Rent(as % of GDP) in Oil in 1995 to that in 1996?
Keep it short and to the point. 0.87. What is the ratio of the Rent(as % of GDP) of Coal in 1995 to that in 1997?
Your answer should be very brief. 1.56. What is the ratio of the Rent(as % of GDP) of Natural Gas in 1995 to that in 1997?
Provide a short and direct response. 0.83. What is the ratio of the Rent(as % of GDP) of Oil in 1995 to that in 1997?
Offer a very short reply. 0.96. What is the ratio of the Rent(as % of GDP) in Coal in 1995 to that in 1998?
Make the answer very short. 3.51. What is the ratio of the Rent(as % of GDP) of Natural Gas in 1995 to that in 1998?
Keep it short and to the point. 1.03. What is the ratio of the Rent(as % of GDP) of Oil in 1995 to that in 1998?
Provide a short and direct response. 1.64. What is the ratio of the Rent(as % of GDP) in Coal in 1995 to that in 1999?
Make the answer very short. 11.27. What is the ratio of the Rent(as % of GDP) in Natural Gas in 1995 to that in 1999?
Give a very brief answer. 1.09. What is the ratio of the Rent(as % of GDP) of Oil in 1995 to that in 1999?
Your answer should be compact. 1.12. What is the ratio of the Rent(as % of GDP) in Coal in 1995 to that in 2000?
Your response must be concise. 4.57. What is the ratio of the Rent(as % of GDP) in Natural Gas in 1995 to that in 2000?
Your answer should be very brief. 0.45. What is the ratio of the Rent(as % of GDP) in Oil in 1995 to that in 2000?
Offer a terse response. 0.66. What is the ratio of the Rent(as % of GDP) of Coal in 1996 to that in 1997?
Your answer should be compact. 1.21. What is the ratio of the Rent(as % of GDP) in Natural Gas in 1996 to that in 1997?
Provide a succinct answer. 1.05. What is the ratio of the Rent(as % of GDP) in Oil in 1996 to that in 1997?
Make the answer very short. 1.11. What is the ratio of the Rent(as % of GDP) in Coal in 1996 to that in 1998?
Make the answer very short. 2.71. What is the ratio of the Rent(as % of GDP) in Natural Gas in 1996 to that in 1998?
Offer a terse response. 1.29. What is the ratio of the Rent(as % of GDP) in Oil in 1996 to that in 1998?
Your answer should be compact. 1.89. What is the ratio of the Rent(as % of GDP) in Coal in 1996 to that in 1999?
Give a very brief answer. 8.7. What is the ratio of the Rent(as % of GDP) in Natural Gas in 1996 to that in 1999?
Provide a succinct answer. 1.36. What is the ratio of the Rent(as % of GDP) in Oil in 1996 to that in 1999?
Make the answer very short. 1.29. What is the ratio of the Rent(as % of GDP) of Coal in 1996 to that in 2000?
Your answer should be compact. 3.53. What is the ratio of the Rent(as % of GDP) in Natural Gas in 1996 to that in 2000?
Your response must be concise. 0.57. What is the ratio of the Rent(as % of GDP) of Oil in 1996 to that in 2000?
Keep it short and to the point. 0.76. What is the ratio of the Rent(as % of GDP) of Coal in 1997 to that in 1998?
Offer a terse response. 2.25. What is the ratio of the Rent(as % of GDP) in Natural Gas in 1997 to that in 1998?
Ensure brevity in your answer.  1.23. What is the ratio of the Rent(as % of GDP) in Oil in 1997 to that in 1998?
Make the answer very short. 1.7. What is the ratio of the Rent(as % of GDP) of Coal in 1997 to that in 1999?
Provide a succinct answer. 7.22. What is the ratio of the Rent(as % of GDP) of Natural Gas in 1997 to that in 1999?
Provide a short and direct response. 1.3. What is the ratio of the Rent(as % of GDP) of Oil in 1997 to that in 1999?
Provide a short and direct response. 1.16. What is the ratio of the Rent(as % of GDP) in Coal in 1997 to that in 2000?
Provide a succinct answer. 2.93. What is the ratio of the Rent(as % of GDP) in Natural Gas in 1997 to that in 2000?
Offer a very short reply. 0.54. What is the ratio of the Rent(as % of GDP) of Oil in 1997 to that in 2000?
Your answer should be compact. 0.69. What is the ratio of the Rent(as % of GDP) of Coal in 1998 to that in 1999?
Provide a succinct answer. 3.21. What is the ratio of the Rent(as % of GDP) in Natural Gas in 1998 to that in 1999?
Give a very brief answer. 1.06. What is the ratio of the Rent(as % of GDP) of Oil in 1998 to that in 1999?
Keep it short and to the point. 0.68. What is the ratio of the Rent(as % of GDP) of Coal in 1998 to that in 2000?
Provide a succinct answer. 1.3. What is the ratio of the Rent(as % of GDP) in Natural Gas in 1998 to that in 2000?
Offer a terse response. 0.44. What is the ratio of the Rent(as % of GDP) of Oil in 1998 to that in 2000?
Give a very brief answer. 0.4. What is the ratio of the Rent(as % of GDP) in Coal in 1999 to that in 2000?
Give a very brief answer. 0.41. What is the ratio of the Rent(as % of GDP) of Natural Gas in 1999 to that in 2000?
Give a very brief answer. 0.42. What is the ratio of the Rent(as % of GDP) in Oil in 1999 to that in 2000?
Provide a short and direct response. 0.59. What is the difference between the highest and the second highest Rent(as % of GDP) in Coal?
Provide a succinct answer. 0.02. What is the difference between the highest and the second highest Rent(as % of GDP) in Natural Gas?
Provide a succinct answer. 0.55. What is the difference between the highest and the second highest Rent(as % of GDP) of Oil?
Make the answer very short. 0.93. What is the difference between the highest and the lowest Rent(as % of GDP) in Coal?
Offer a very short reply. 0.08. What is the difference between the highest and the lowest Rent(as % of GDP) of Natural Gas?
Offer a terse response. 0.73. What is the difference between the highest and the lowest Rent(as % of GDP) of Oil?
Offer a terse response. 2.53. 